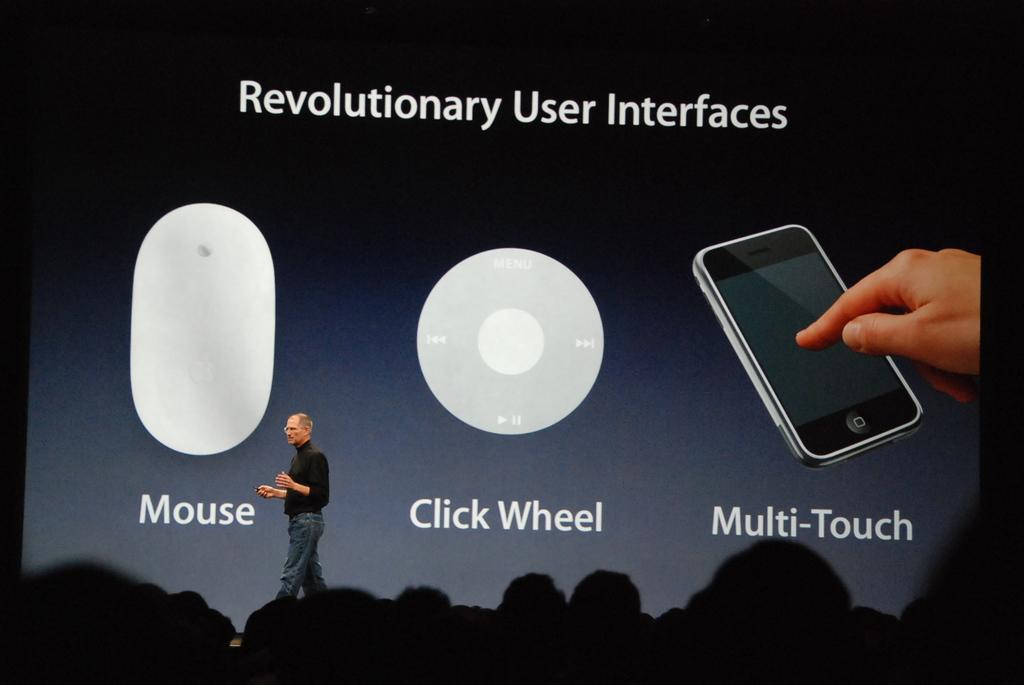<image>
Create a compact narrative representing the image presented. A man standing on a stage in front of a screen displaying a title Revolutionary User Interface mouse, click wheel and multi touch. 